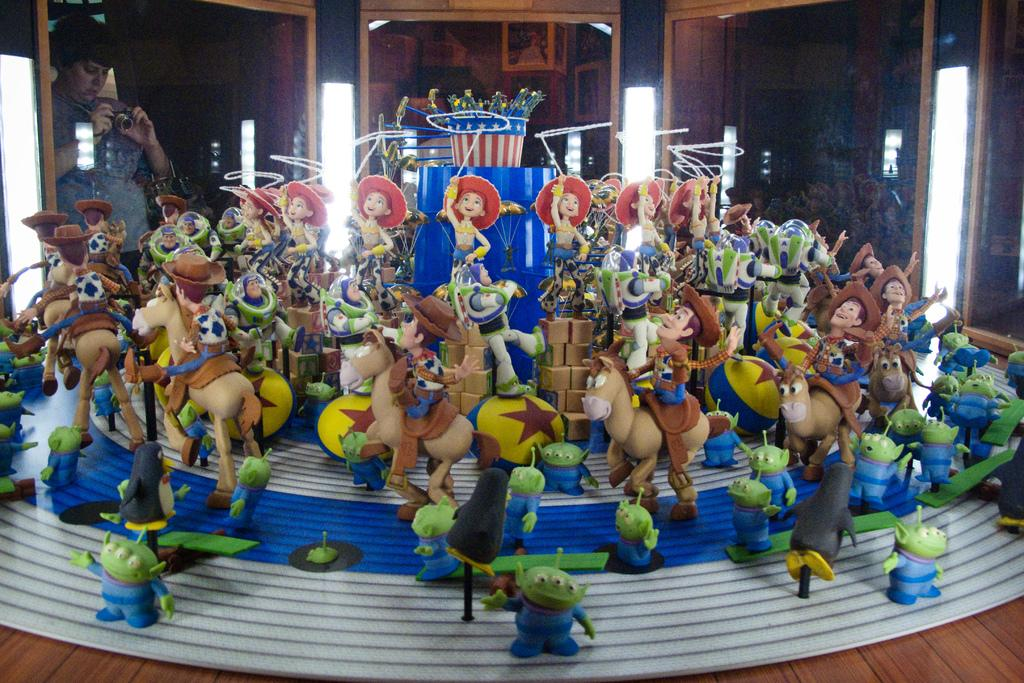What objects can be seen on the surface in the image? There are toys on the surface in the image. Where is the person in the image positioned? There is a person standing on the left side of the image, holding a camera. What type of windows are visible in the image? There are glass windows in the image. What can be found on the wooden wall in the image? There are photo frames on a wooden wall in the image. What part of the man's body is visible in the image? There is no man present in the image; only a person holding a camera is visible. What view can be seen through the glass windows in the image? The provided facts do not mention a view through the glass windows, only that they are visible in the image. 